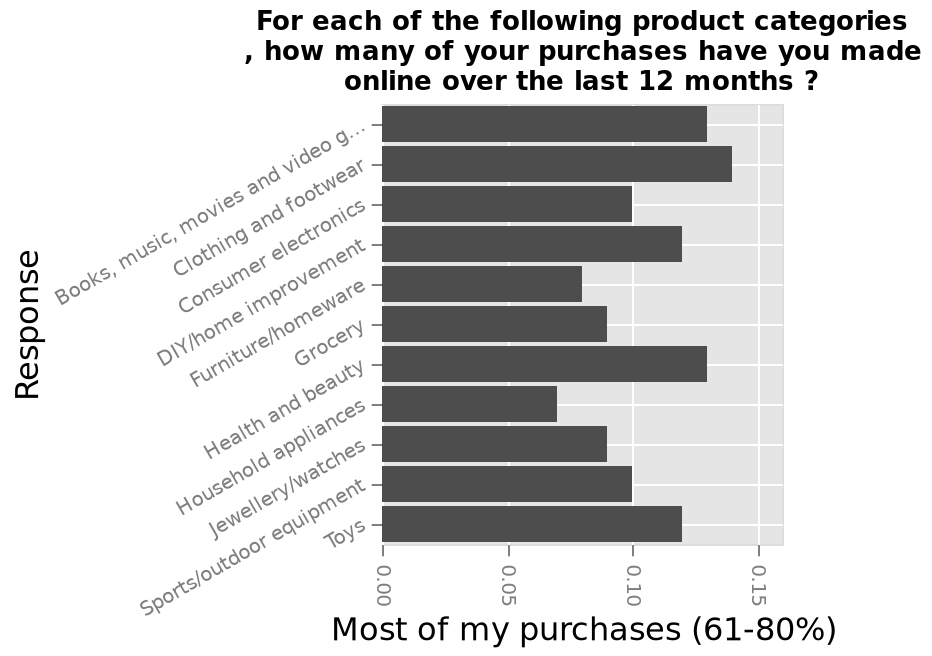<image>
Describe the following image in detail This bar graph is called For each of the following product categories , how many of your purchases have you made online over the last 12 months ?. There is a categorical scale from Books, music, movies and video games to Toys on the y-axis, labeled Response. A scale of range 0.00 to 0.15 can be found on the x-axis, labeled Most of my purchases (61-80%). Which category has the highest number of online purchases?  The bar graph does not provide information about which category has the highest number of online purchases. What are the top two categories for online purchases?  The top two categories for online purchases are clothing and footwear, followed by household appliances. please summary the statistics and relations of the chart The most purchases that have been made online are for clothing and footwear. Household appliances are the category with the least amount of purchases being made online. What does the y-axis of the bar graph represent?  The y-axis of the bar graph represents different product categories from Books, music, movies and video games to Toys. 